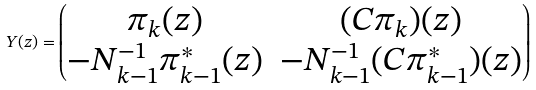<formula> <loc_0><loc_0><loc_500><loc_500>Y ( z ) = \begin{pmatrix} \pi _ { k } ( z ) & ( C \pi _ { k } ) ( z ) \\ - N _ { k - 1 } ^ { - 1 } \pi ^ { * } _ { k - 1 } ( z ) & - N _ { k - 1 } ^ { - 1 } ( C \pi ^ { * } _ { k - 1 } ) ( z ) \end{pmatrix}</formula> 